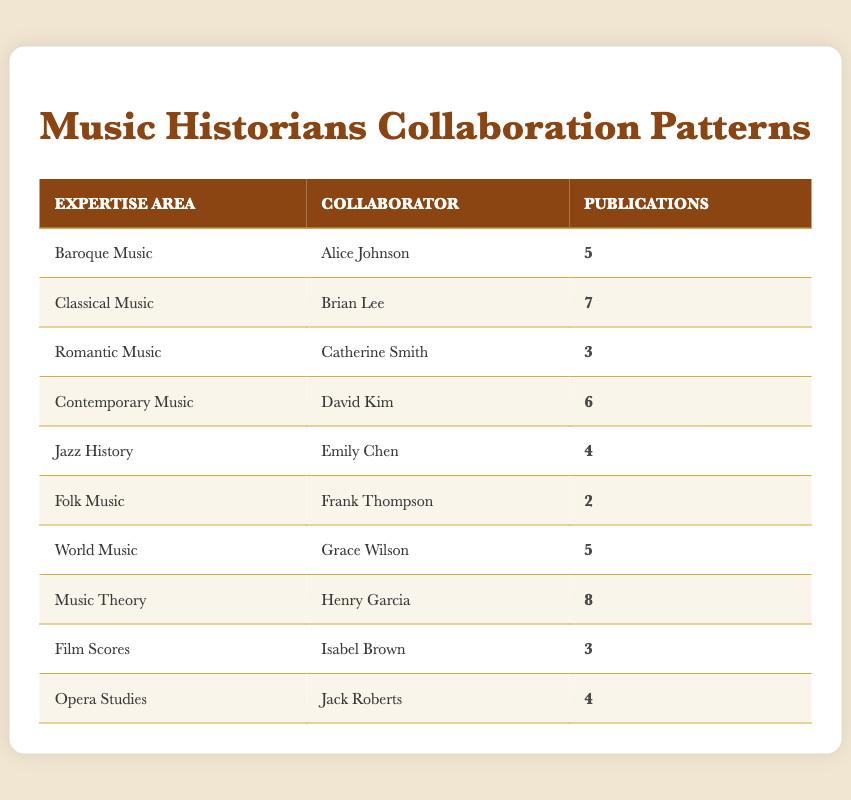What is the highest number of publications among collaborators? By scanning the publications column, we see that the collaborator with the highest number of publications is Henry Garcia, who has 8 publications.
Answer: 8 Which expertise area has the least number of publications? Looking through the publications column, Folk Music has the least number of publications, with only 2.
Answer: Folk Music Who are the collaborators in the field of Romantic Music and Jazz History? In the Romantic Music row, the collaborator is Catherine Smith, and in the Jazz History row, it is Emily Chen.
Answer: Catherine Smith and Emily Chen What is the total number of publications by Alice Johnson and David Kim combined? Adding Alice Johnson's publications (5) to David Kim's (6), we have: 5 + 6 = 11.
Answer: 11 Is there a collaborator in the table associated with both Classical Music and Film Scores? Checking through the table, Brian Lee is listed for Classical Music, and Isabel Brown is associated with Film Scores. There is no single collaborator linked to both expertise areas.
Answer: No What is the average number of publications for all collaborators listed? To find the average, we first sum all publications: 5 + 7 + 3 + 6 + 4 + 2 + 5 + 8 + 3 + 4 = 43. Then, we divide by the total number of collaborators (10): 43 / 10 = 4.3.
Answer: 4.3 Which expertise area has more publications, Baroque Music or World Music? Baroque Music has 5 publications while World Music also has 5 publications. Both areas have the same number of publications.
Answer: They are equal How many publications does the Music Theory collaborator have compared to the total in the table? Henry Garcia has 8 publications; the total publications in the table is 43. 8 is less than half of 43, specifically it is around 18.6%.
Answer: 8 Which area has a higher number of publications: Contemporary Music or Opera Studies? Contemporary Music has 6 publications, while Opera Studies has 4. By comparing these two numbers, it is clear that Contemporary Music has more publications by 2.
Answer: Contemporary Music 